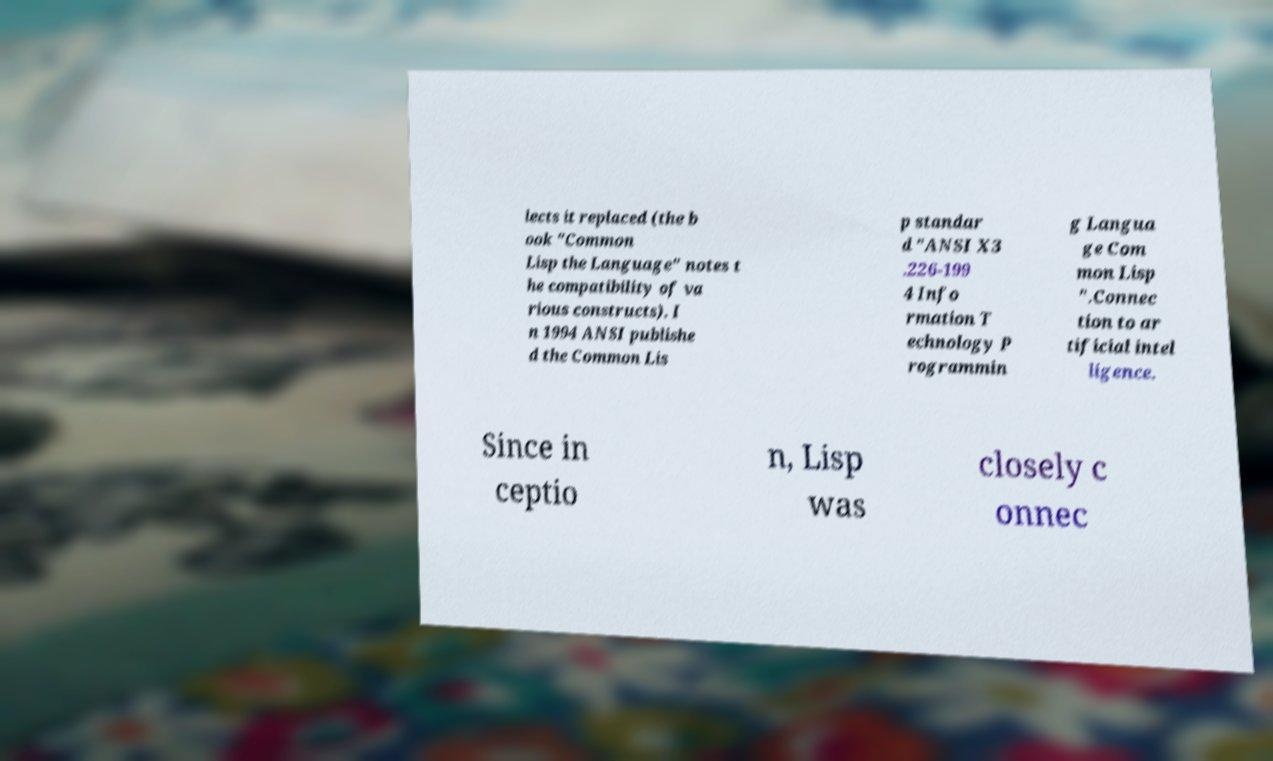What messages or text are displayed in this image? I need them in a readable, typed format. lects it replaced (the b ook "Common Lisp the Language" notes t he compatibility of va rious constructs). I n 1994 ANSI publishe d the Common Lis p standar d "ANSI X3 .226-199 4 Info rmation T echnology P rogrammin g Langua ge Com mon Lisp ".Connec tion to ar tificial intel ligence. Since in ceptio n, Lisp was closely c onnec 